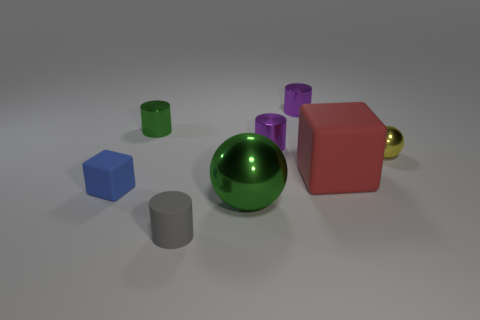Subtract all small gray cylinders. How many cylinders are left? 3 Subtract all green cylinders. How many cylinders are left? 3 Subtract all cyan cylinders. Subtract all yellow spheres. How many cylinders are left? 4 Add 1 tiny purple matte spheres. How many objects exist? 9 Subtract all balls. How many objects are left? 6 Subtract 2 purple cylinders. How many objects are left? 6 Subtract all red rubber things. Subtract all tiny blue things. How many objects are left? 6 Add 2 small yellow metallic objects. How many small yellow metallic objects are left? 3 Add 2 tiny yellow shiny balls. How many tiny yellow shiny balls exist? 3 